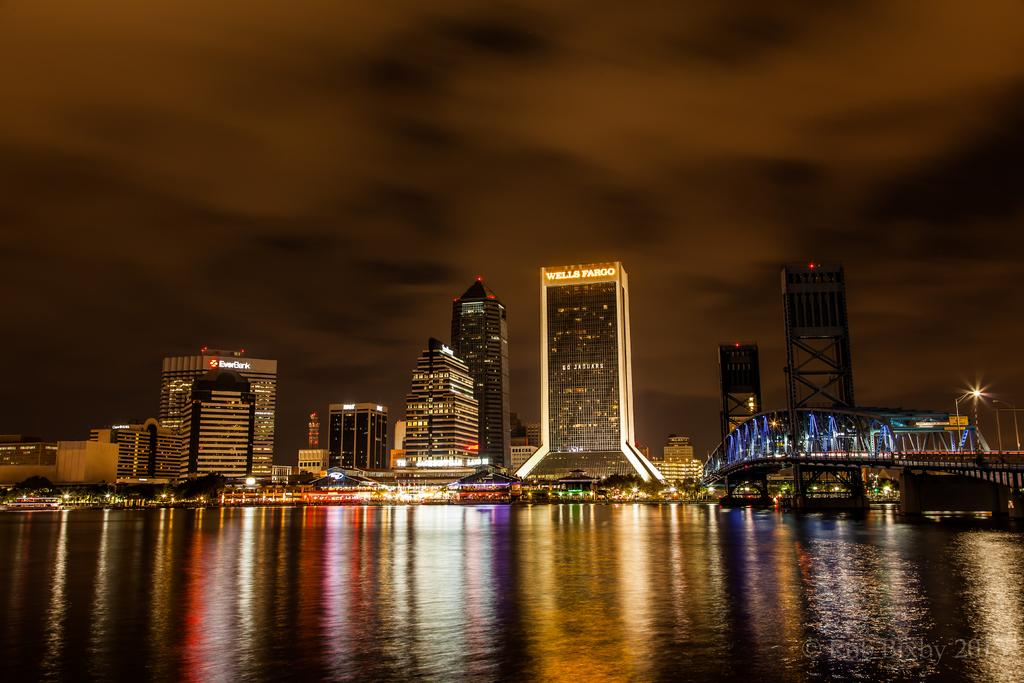<image>
Provide a brief description of the given image. Wells Fargo sponsors one of the taller buildings along the waterfront. 